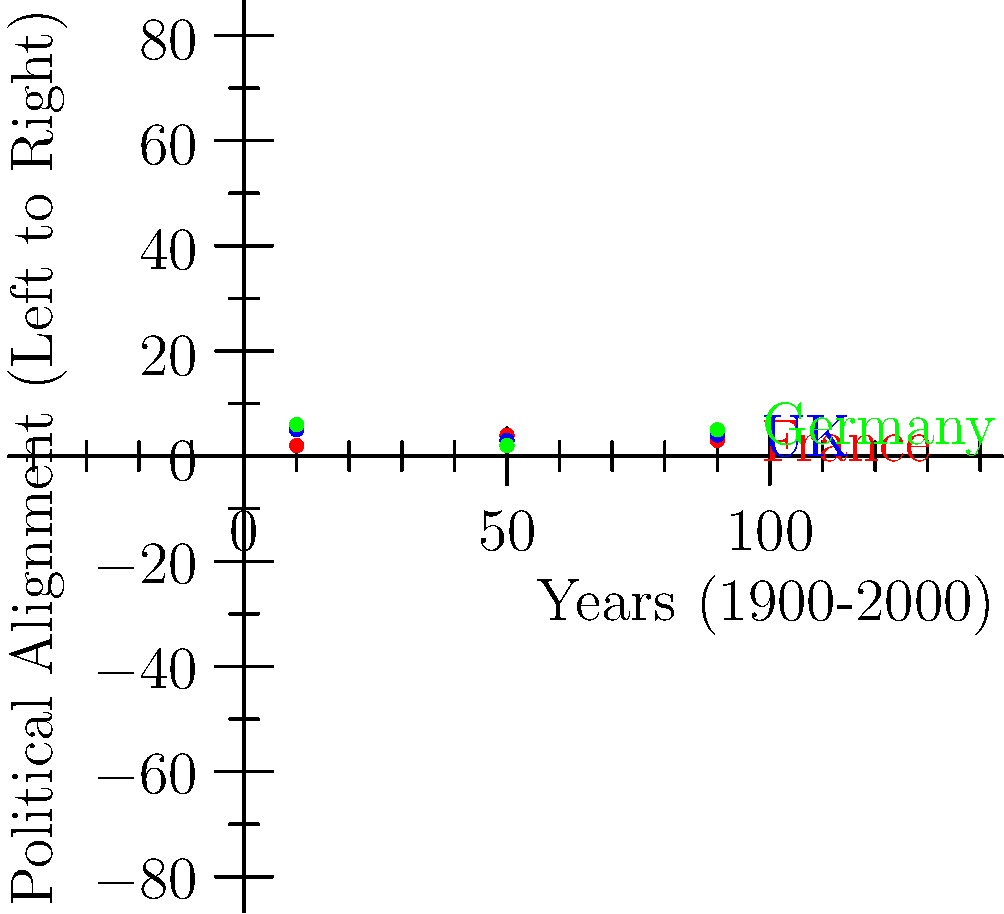Analyze the scatter plot showing the political alignment of France, the UK, and Germany from 1900 to 2000. Which country experienced the most significant rightward shift in its political alignment between 1950 and 1990? To determine which country experienced the most significant rightward shift between 1950 and 1990, we need to compare the change in y-axis values (political alignment) for each country:

1. France:
   1950: y ≈ 4
   1990: y ≈ 3
   Change: 3 - 4 = -1 (leftward shift)

2. UK:
   1950: y ≈ 3
   1990: y ≈ 4
   Change: 4 - 3 = +1 (rightward shift)

3. Germany:
   1950: y ≈ 2
   1990: y ≈ 5
   Change: 5 - 2 = +3 (rightward shift)

Germany shows the largest positive change in y-value, indicating the most significant rightward shift in political alignment between 1950 and 1990.
Answer: Germany 